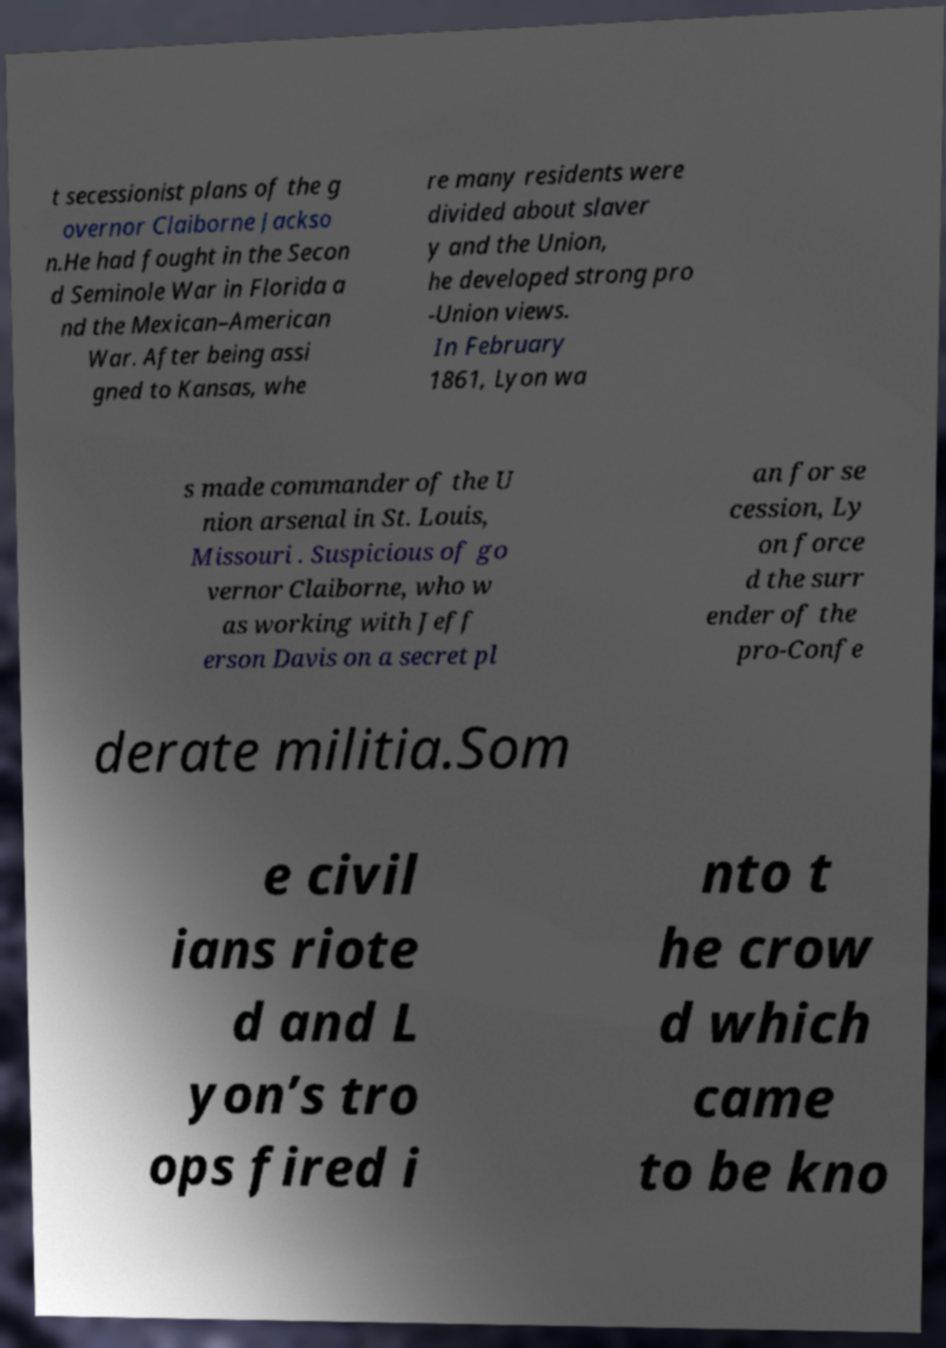Can you accurately transcribe the text from the provided image for me? t secessionist plans of the g overnor Claiborne Jackso n.He had fought in the Secon d Seminole War in Florida a nd the Mexican–American War. After being assi gned to Kansas, whe re many residents were divided about slaver y and the Union, he developed strong pro -Union views. In February 1861, Lyon wa s made commander of the U nion arsenal in St. Louis, Missouri . Suspicious of go vernor Claiborne, who w as working with Jeff erson Davis on a secret pl an for se cession, Ly on force d the surr ender of the pro-Confe derate militia.Som e civil ians riote d and L yon’s tro ops fired i nto t he crow d which came to be kno 